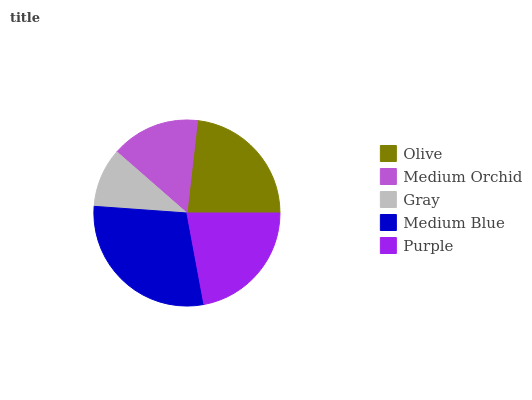Is Gray the minimum?
Answer yes or no. Yes. Is Medium Blue the maximum?
Answer yes or no. Yes. Is Medium Orchid the minimum?
Answer yes or no. No. Is Medium Orchid the maximum?
Answer yes or no. No. Is Olive greater than Medium Orchid?
Answer yes or no. Yes. Is Medium Orchid less than Olive?
Answer yes or no. Yes. Is Medium Orchid greater than Olive?
Answer yes or no. No. Is Olive less than Medium Orchid?
Answer yes or no. No. Is Purple the high median?
Answer yes or no. Yes. Is Purple the low median?
Answer yes or no. Yes. Is Olive the high median?
Answer yes or no. No. Is Olive the low median?
Answer yes or no. No. 